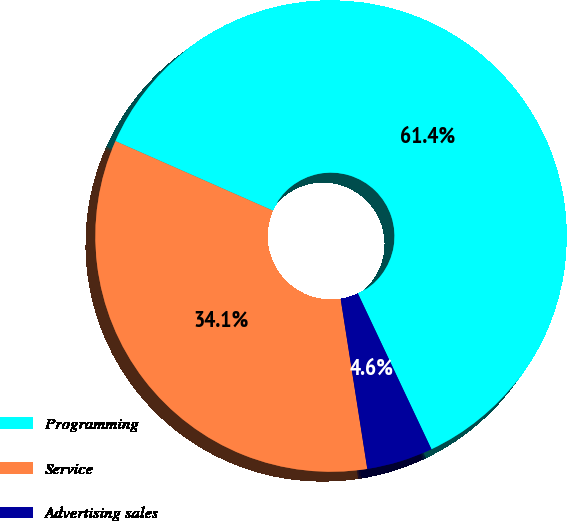Convert chart. <chart><loc_0><loc_0><loc_500><loc_500><pie_chart><fcel>Programming<fcel>Service<fcel>Advertising sales<nl><fcel>61.36%<fcel>34.09%<fcel>4.55%<nl></chart> 